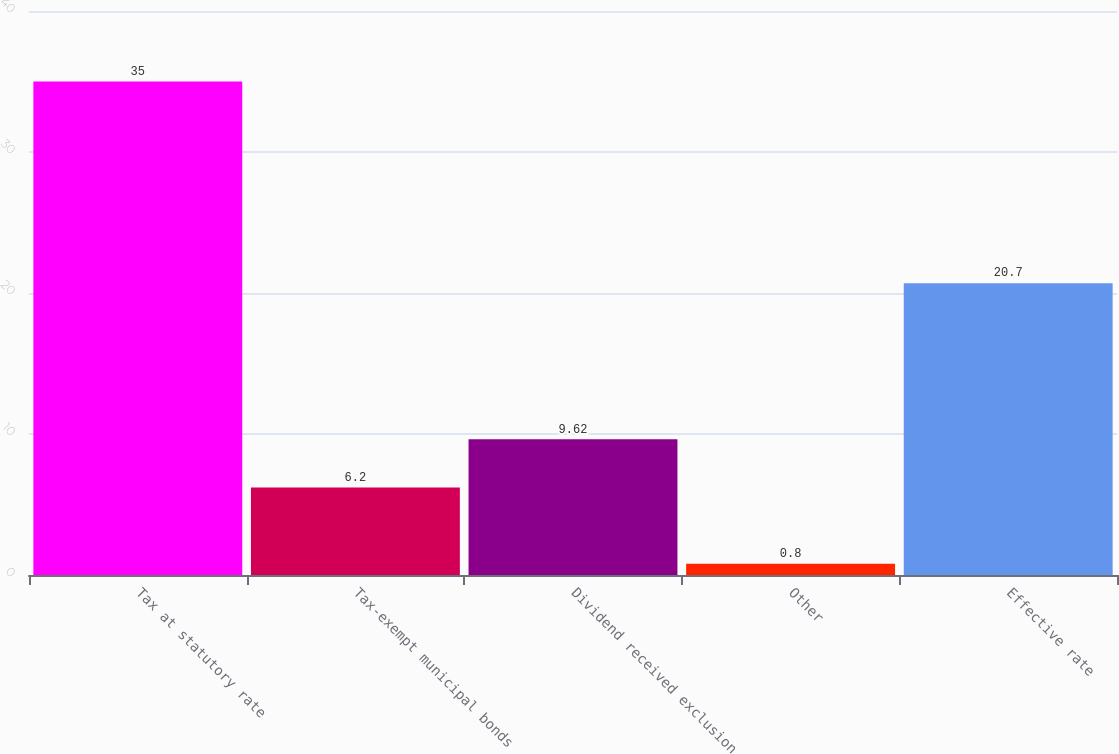Convert chart to OTSL. <chart><loc_0><loc_0><loc_500><loc_500><bar_chart><fcel>Tax at statutory rate<fcel>Tax-exempt municipal bonds<fcel>Dividend received exclusion<fcel>Other<fcel>Effective rate<nl><fcel>35<fcel>6.2<fcel>9.62<fcel>0.8<fcel>20.7<nl></chart> 